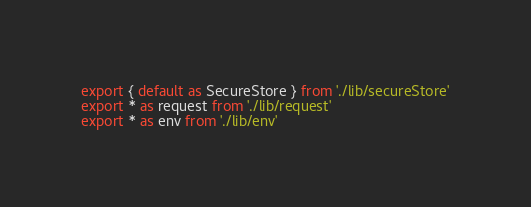<code> <loc_0><loc_0><loc_500><loc_500><_TypeScript_>export { default as SecureStore } from './lib/secureStore'
export * as request from './lib/request'
export * as env from './lib/env'
</code> 